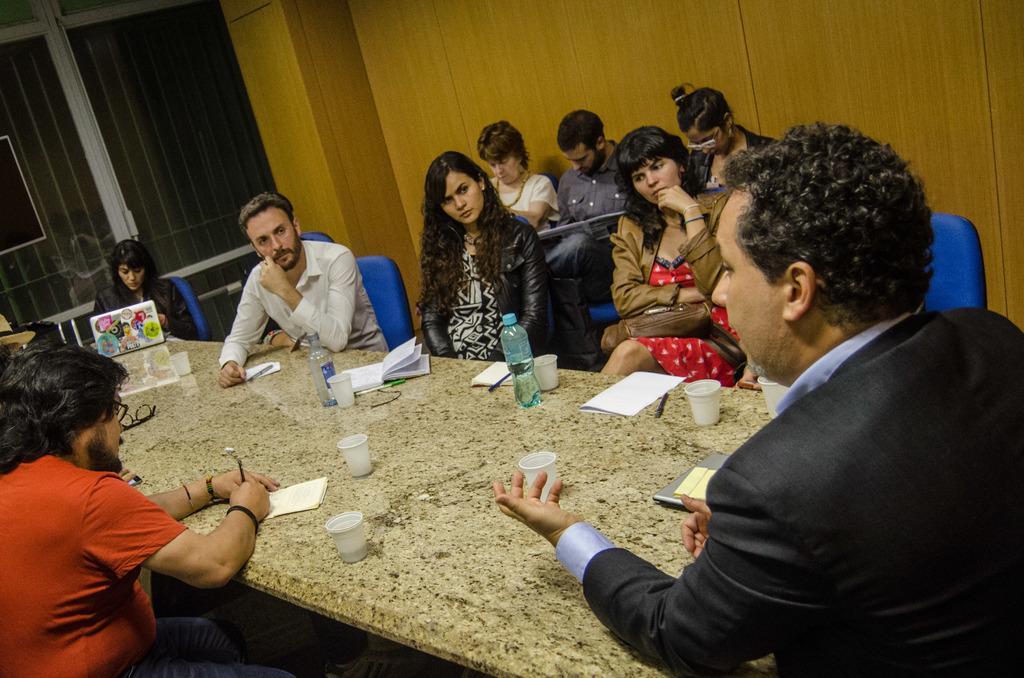Could you give a brief overview of what you see in this image? There are many people sitting around the table in their chairs. On the table there are some glasses, Water bottles, papers, pens, etc. There are some people in the background sitting in the chairs. We can observe a wall here. 